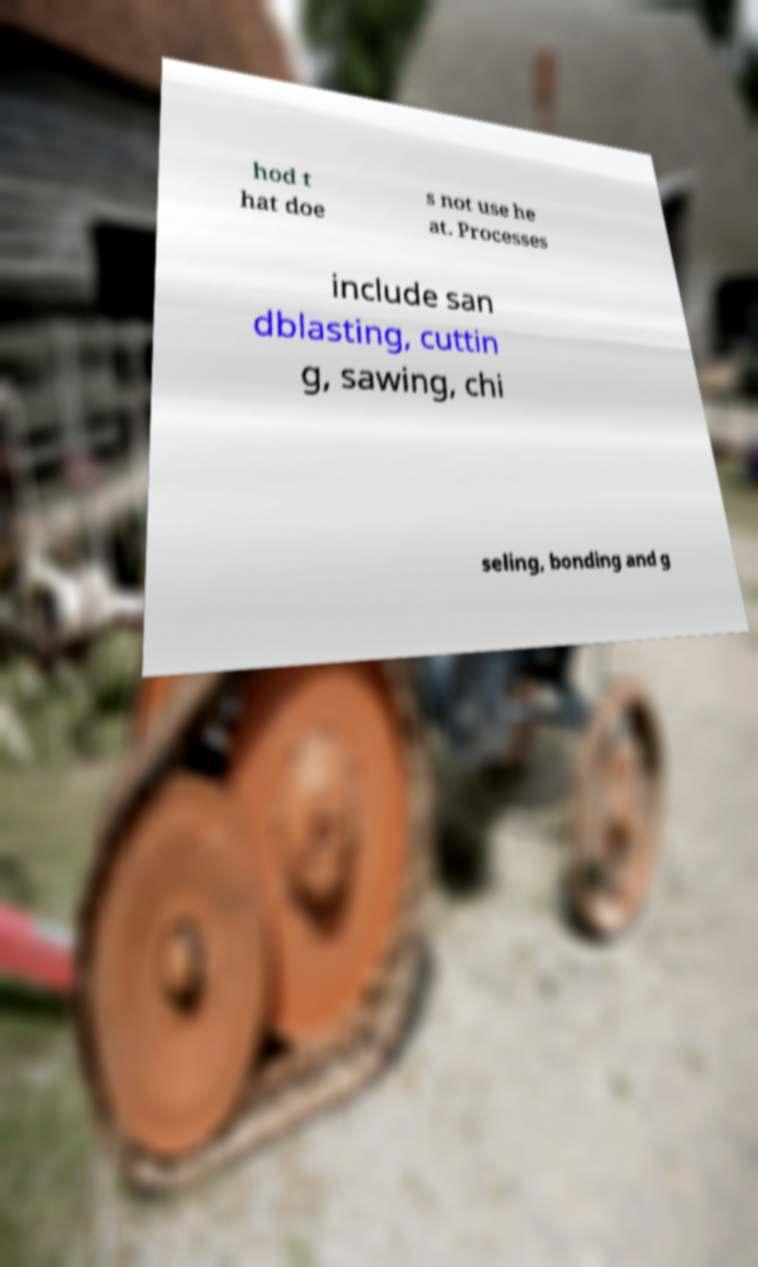Could you extract and type out the text from this image? hod t hat doe s not use he at. Processes include san dblasting, cuttin g, sawing, chi seling, bonding and g 